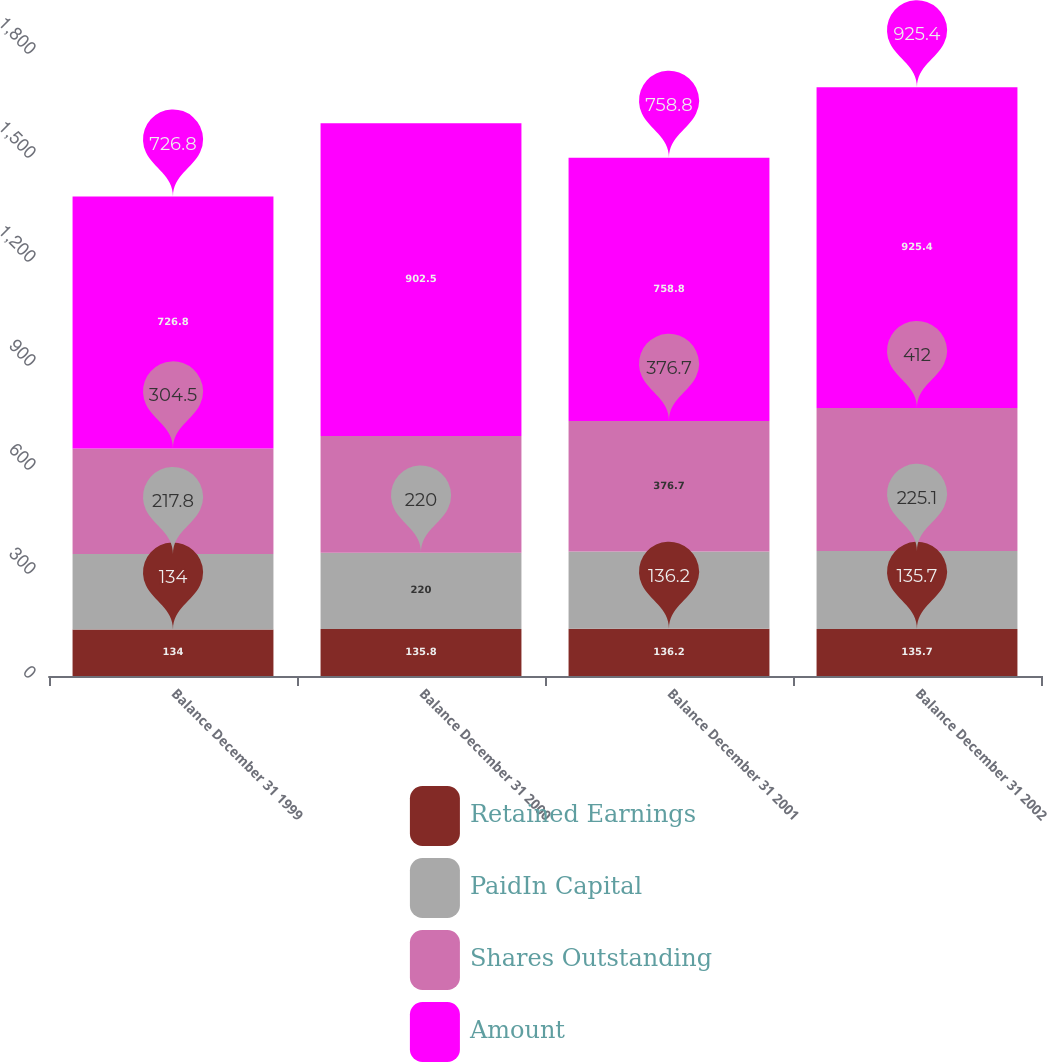Convert chart. <chart><loc_0><loc_0><loc_500><loc_500><stacked_bar_chart><ecel><fcel>Balance December 31 1999<fcel>Balance December 31 2000<fcel>Balance December 31 2001<fcel>Balance December 31 2002<nl><fcel>Retained Earnings<fcel>134<fcel>135.8<fcel>136.2<fcel>135.7<nl><fcel>PaidIn Capital<fcel>217.8<fcel>220<fcel>223<fcel>225.1<nl><fcel>Shares Outstanding<fcel>304.5<fcel>336.5<fcel>376.7<fcel>412<nl><fcel>Amount<fcel>726.8<fcel>902.5<fcel>758.8<fcel>925.4<nl></chart> 